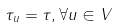<formula> <loc_0><loc_0><loc_500><loc_500>\tau _ { u } = \tau , \forall u \in V</formula> 